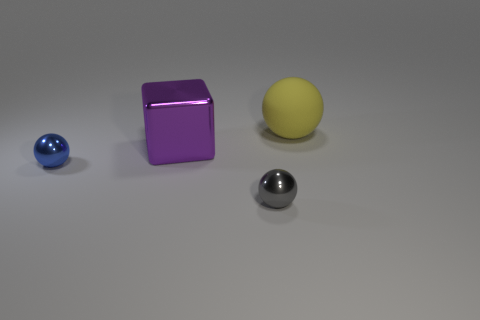There is a object that is the same size as the yellow rubber ball; what is its color?
Your response must be concise. Purple. Are there an equal number of large metal things that are to the right of the yellow rubber sphere and big blue metal balls?
Ensure brevity in your answer.  Yes. There is a thing that is in front of the matte object and to the right of the large metal object; what is its shape?
Your answer should be compact. Sphere. Does the purple metal object have the same size as the blue shiny ball?
Provide a succinct answer. No. Is there a blue cube that has the same material as the small gray ball?
Give a very brief answer. No. What number of objects are behind the blue metallic sphere and in front of the large matte sphere?
Offer a terse response. 1. There is a tiny gray object that is to the right of the tiny blue metal thing; what material is it?
Make the answer very short. Metal. What number of other big metallic blocks are the same color as the shiny block?
Provide a short and direct response. 0. There is a blue thing that is the same material as the big block; what is its size?
Make the answer very short. Small. How many things are either big spheres or small metal things?
Provide a succinct answer. 3. 